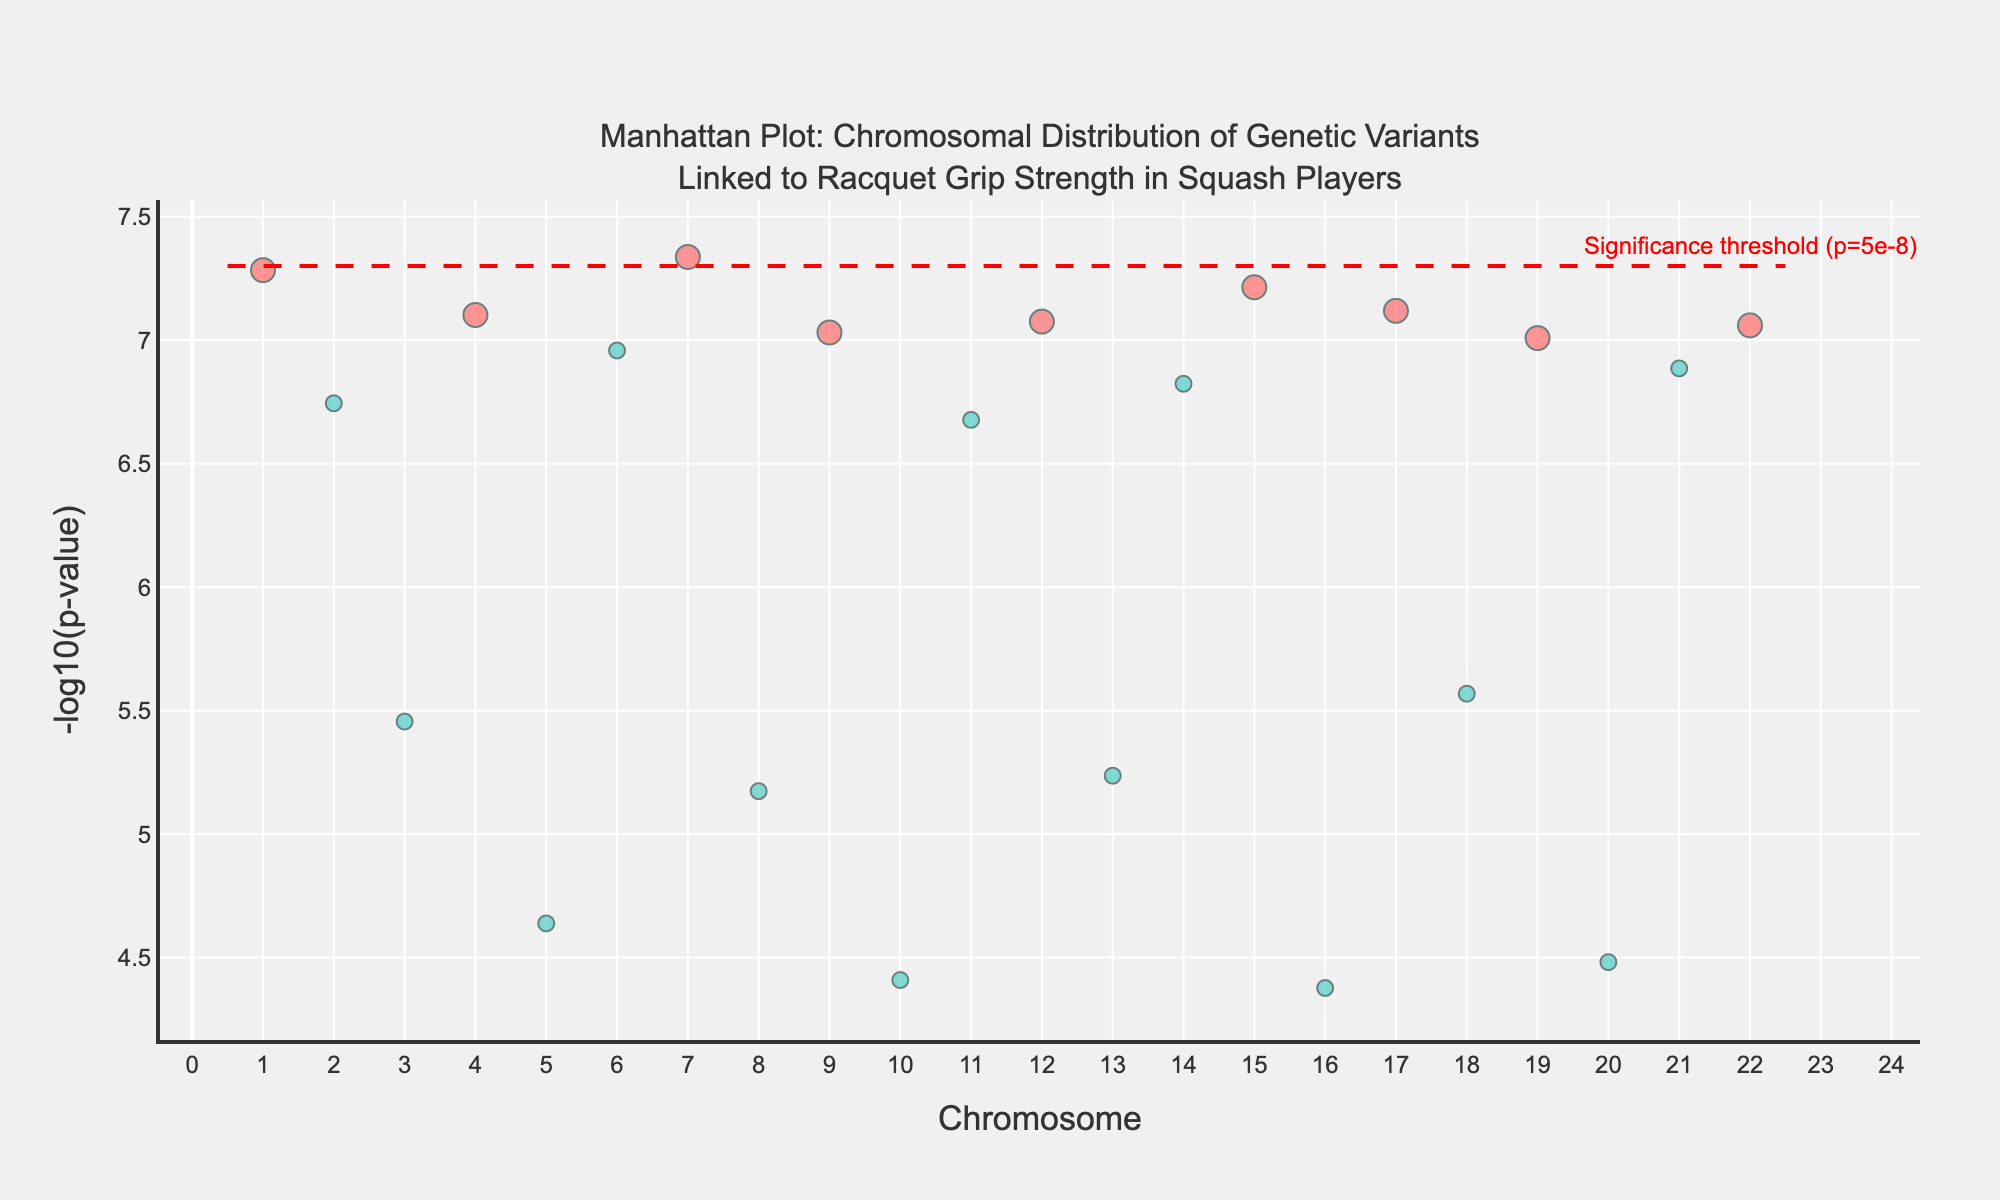How many data points are displayed in the plot? Count all the markers on the plot. There are 22 data points shown, one for each chromosome.
Answer: 22 What is the title of the plot? Read the title at the top of the plot. It states "Manhattan Plot: Chromosomal Distribution of Genetic Variants Linked to Racquet Grip Strength in Squash Players."
Answer: Manhattan Plot: Chromosomal Distribution of Genetic Variants Linked to Racquet Grip Strength in Squash Players Which chromosome has the highest -log10(p-value)? Identify the marker with the highest y-value on the y-axis and note its corresponding chromosome on the x-axis. Chromosome 4 has the highest -log10(p-value).
Answer: Chromosome 4 How many significant variants are there? Count the number of red markers. There are 12 significant variants.
Answer: 12 Which gene has the lowest p-value? Find the highest -log10(p-value) marker, then check the hover text for that marker. The gene is COL5A1.
Answer: COL5A1 Which chromosomes have significant variants? Identify all chromosomes with red markers. The chromosomes are 1, 4, 7, 9, 12, 15, 17, 19, and 22.
Answer: 1, 4, 7, 9, 12, 15, 17, 19, 22 Which chromosome has the most genetic variants linked to racquet grip strength? Identify the chromosome with the most markers. Chromosomes 2 and 11 both have 2 variants each.
Answer: Chromosomes 2 and 11 What is the significance threshold for p-values in the plot? Look at the red dashed line and the corresponding annotation. It indicates "Significance threshold (p=5e-8)."
Answer: 5e-8 How many chromosomes have no significant genetic variants? Count the number of chromosomes that do not have any red markers. There are 13 chromosomes with no significant genetic variants.
Answer: 13 Which gene is located on Chromosome 7? Locate the marker on Chromosome 7 and read the hover text to find the associated gene. The gene is COL1A2.
Answer: COL1A2 